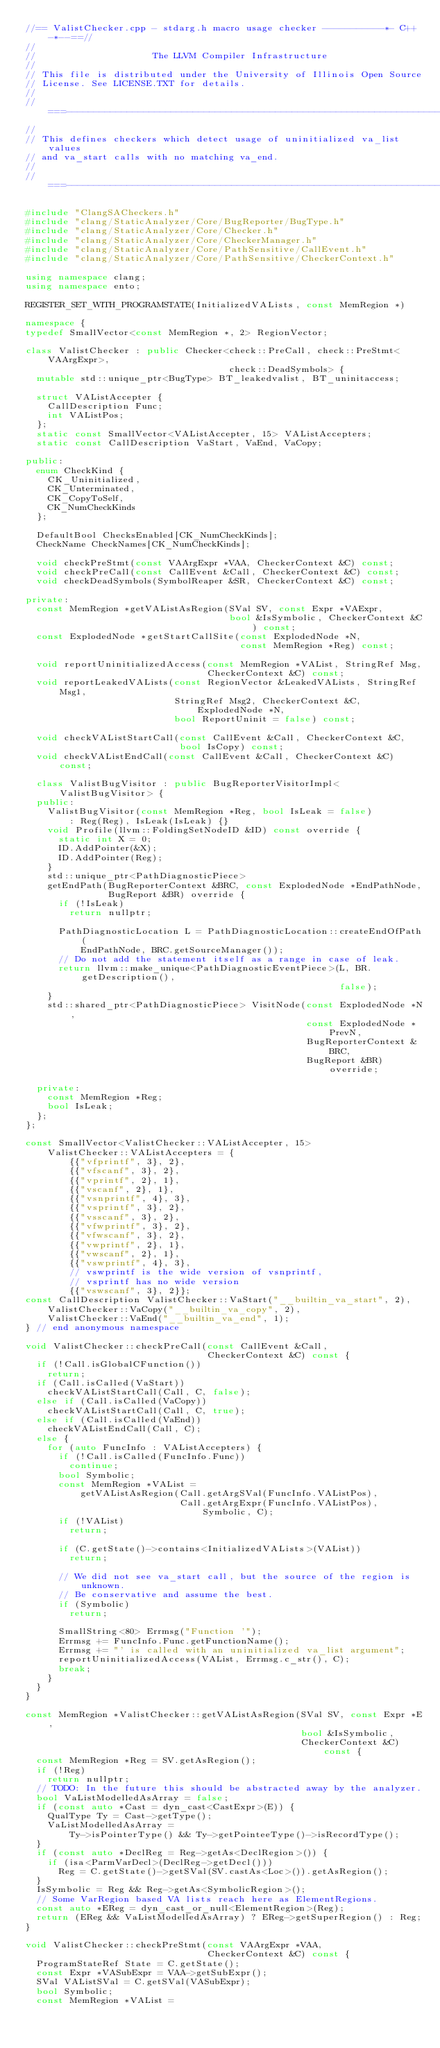<code> <loc_0><loc_0><loc_500><loc_500><_C++_>//== ValistChecker.cpp - stdarg.h macro usage checker -----------*- C++ -*--==//
//
//                     The LLVM Compiler Infrastructure
//
// This file is distributed under the University of Illinois Open Source
// License. See LICENSE.TXT for details.
//
//===----------------------------------------------------------------------===//
//
// This defines checkers which detect usage of uninitialized va_list values
// and va_start calls with no matching va_end.
//
//===----------------------------------------------------------------------===//

#include "ClangSACheckers.h"
#include "clang/StaticAnalyzer/Core/BugReporter/BugType.h"
#include "clang/StaticAnalyzer/Core/Checker.h"
#include "clang/StaticAnalyzer/Core/CheckerManager.h"
#include "clang/StaticAnalyzer/Core/PathSensitive/CallEvent.h"
#include "clang/StaticAnalyzer/Core/PathSensitive/CheckerContext.h"

using namespace clang;
using namespace ento;

REGISTER_SET_WITH_PROGRAMSTATE(InitializedVALists, const MemRegion *)

namespace {
typedef SmallVector<const MemRegion *, 2> RegionVector;

class ValistChecker : public Checker<check::PreCall, check::PreStmt<VAArgExpr>,
                                     check::DeadSymbols> {
  mutable std::unique_ptr<BugType> BT_leakedvalist, BT_uninitaccess;

  struct VAListAccepter {
    CallDescription Func;
    int VAListPos;
  };
  static const SmallVector<VAListAccepter, 15> VAListAccepters;
  static const CallDescription VaStart, VaEnd, VaCopy;

public:
  enum CheckKind {
    CK_Uninitialized,
    CK_Unterminated,
    CK_CopyToSelf,
    CK_NumCheckKinds
  };

  DefaultBool ChecksEnabled[CK_NumCheckKinds];
  CheckName CheckNames[CK_NumCheckKinds];

  void checkPreStmt(const VAArgExpr *VAA, CheckerContext &C) const;
  void checkPreCall(const CallEvent &Call, CheckerContext &C) const;
  void checkDeadSymbols(SymbolReaper &SR, CheckerContext &C) const;

private:
  const MemRegion *getVAListAsRegion(SVal SV, const Expr *VAExpr,
                                     bool &IsSymbolic, CheckerContext &C) const;
  const ExplodedNode *getStartCallSite(const ExplodedNode *N,
                                       const MemRegion *Reg) const;

  void reportUninitializedAccess(const MemRegion *VAList, StringRef Msg,
                                 CheckerContext &C) const;
  void reportLeakedVALists(const RegionVector &LeakedVALists, StringRef Msg1,
                           StringRef Msg2, CheckerContext &C, ExplodedNode *N,
                           bool ReportUninit = false) const;

  void checkVAListStartCall(const CallEvent &Call, CheckerContext &C,
                            bool IsCopy) const;
  void checkVAListEndCall(const CallEvent &Call, CheckerContext &C) const;

  class ValistBugVisitor : public BugReporterVisitorImpl<ValistBugVisitor> {
  public:
    ValistBugVisitor(const MemRegion *Reg, bool IsLeak = false)
        : Reg(Reg), IsLeak(IsLeak) {}
    void Profile(llvm::FoldingSetNodeID &ID) const override {
      static int X = 0;
      ID.AddPointer(&X);
      ID.AddPointer(Reg);
    }
    std::unique_ptr<PathDiagnosticPiece>
    getEndPath(BugReporterContext &BRC, const ExplodedNode *EndPathNode,
               BugReport &BR) override {
      if (!IsLeak)
        return nullptr;

      PathDiagnosticLocation L = PathDiagnosticLocation::createEndOfPath(
          EndPathNode, BRC.getSourceManager());
      // Do not add the statement itself as a range in case of leak.
      return llvm::make_unique<PathDiagnosticEventPiece>(L, BR.getDescription(),
                                                         false);
    }
    std::shared_ptr<PathDiagnosticPiece> VisitNode(const ExplodedNode *N,
                                                   const ExplodedNode *PrevN,
                                                   BugReporterContext &BRC,
                                                   BugReport &BR) override;

  private:
    const MemRegion *Reg;
    bool IsLeak;
  };
};

const SmallVector<ValistChecker::VAListAccepter, 15>
    ValistChecker::VAListAccepters = {
        {{"vfprintf", 3}, 2},
        {{"vfscanf", 3}, 2},
        {{"vprintf", 2}, 1},
        {{"vscanf", 2}, 1},
        {{"vsnprintf", 4}, 3},
        {{"vsprintf", 3}, 2},
        {{"vsscanf", 3}, 2},
        {{"vfwprintf", 3}, 2},
        {{"vfwscanf", 3}, 2},
        {{"vwprintf", 2}, 1},
        {{"vwscanf", 2}, 1},
        {{"vswprintf", 4}, 3},
        // vswprintf is the wide version of vsnprintf,
        // vsprintf has no wide version
        {{"vswscanf", 3}, 2}};
const CallDescription ValistChecker::VaStart("__builtin_va_start", 2),
    ValistChecker::VaCopy("__builtin_va_copy", 2),
    ValistChecker::VaEnd("__builtin_va_end", 1);
} // end anonymous namespace

void ValistChecker::checkPreCall(const CallEvent &Call,
                                 CheckerContext &C) const {
  if (!Call.isGlobalCFunction())
    return;
  if (Call.isCalled(VaStart))
    checkVAListStartCall(Call, C, false);
  else if (Call.isCalled(VaCopy))
    checkVAListStartCall(Call, C, true);
  else if (Call.isCalled(VaEnd))
    checkVAListEndCall(Call, C);
  else {
    for (auto FuncInfo : VAListAccepters) {
      if (!Call.isCalled(FuncInfo.Func))
        continue;
      bool Symbolic;
      const MemRegion *VAList =
          getVAListAsRegion(Call.getArgSVal(FuncInfo.VAListPos),
                            Call.getArgExpr(FuncInfo.VAListPos), Symbolic, C);
      if (!VAList)
        return;

      if (C.getState()->contains<InitializedVALists>(VAList))
        return;

      // We did not see va_start call, but the source of the region is unknown.
      // Be conservative and assume the best.
      if (Symbolic)
        return;

      SmallString<80> Errmsg("Function '");
      Errmsg += FuncInfo.Func.getFunctionName();
      Errmsg += "' is called with an uninitialized va_list argument";
      reportUninitializedAccess(VAList, Errmsg.c_str(), C);
      break;
    }
  }
}

const MemRegion *ValistChecker::getVAListAsRegion(SVal SV, const Expr *E,
                                                  bool &IsSymbolic,
                                                  CheckerContext &C) const {
  const MemRegion *Reg = SV.getAsRegion();
  if (!Reg)
    return nullptr;
  // TODO: In the future this should be abstracted away by the analyzer.
  bool VaListModelledAsArray = false;
  if (const auto *Cast = dyn_cast<CastExpr>(E)) {
    QualType Ty = Cast->getType();
    VaListModelledAsArray =
        Ty->isPointerType() && Ty->getPointeeType()->isRecordType();
  }
  if (const auto *DeclReg = Reg->getAs<DeclRegion>()) {
    if (isa<ParmVarDecl>(DeclReg->getDecl()))
      Reg = C.getState()->getSVal(SV.castAs<Loc>()).getAsRegion();
  }
  IsSymbolic = Reg && Reg->getAs<SymbolicRegion>();
  // Some VarRegion based VA lists reach here as ElementRegions.
  const auto *EReg = dyn_cast_or_null<ElementRegion>(Reg);
  return (EReg && VaListModelledAsArray) ? EReg->getSuperRegion() : Reg;
}

void ValistChecker::checkPreStmt(const VAArgExpr *VAA,
                                 CheckerContext &C) const {
  ProgramStateRef State = C.getState();
  const Expr *VASubExpr = VAA->getSubExpr();
  SVal VAListSVal = C.getSVal(VASubExpr);
  bool Symbolic;
  const MemRegion *VAList =</code> 